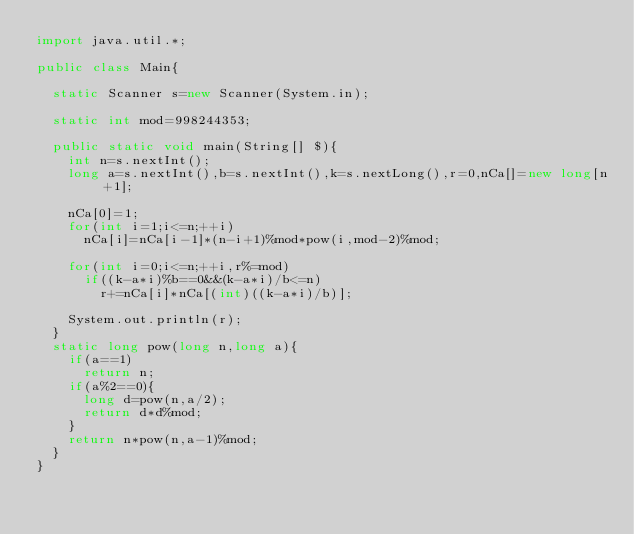Convert code to text. <code><loc_0><loc_0><loc_500><loc_500><_Java_>import java.util.*;

public class Main{

	static Scanner s=new Scanner(System.in);

	static int mod=998244353;

	public static void main(String[] $){
		int n=s.nextInt();
		long a=s.nextInt(),b=s.nextInt(),k=s.nextLong(),r=0,nCa[]=new long[n+1];
		
		nCa[0]=1;
		for(int i=1;i<=n;++i)
			nCa[i]=nCa[i-1]*(n-i+1)%mod*pow(i,mod-2)%mod;

		for(int i=0;i<=n;++i,r%=mod)
			if((k-a*i)%b==0&&(k-a*i)/b<=n)
				r+=nCa[i]*nCa[(int)((k-a*i)/b)];
		
		System.out.println(r);
	}
	static long pow(long n,long a){
		if(a==1)
			return n;
		if(a%2==0){
			long d=pow(n,a/2);
			return d*d%mod;
		}
		return n*pow(n,a-1)%mod;
	}
}</code> 